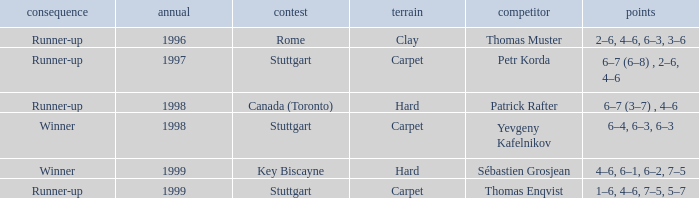What transpired before the year 1997? Runner-up. 